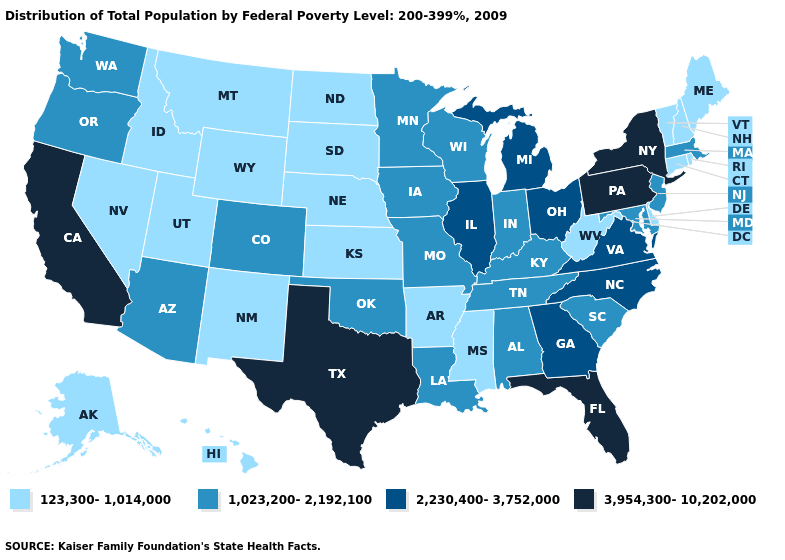What is the value of Hawaii?
Be succinct. 123,300-1,014,000. What is the value of Mississippi?
Concise answer only. 123,300-1,014,000. Which states have the lowest value in the USA?
Quick response, please. Alaska, Arkansas, Connecticut, Delaware, Hawaii, Idaho, Kansas, Maine, Mississippi, Montana, Nebraska, Nevada, New Hampshire, New Mexico, North Dakota, Rhode Island, South Dakota, Utah, Vermont, West Virginia, Wyoming. Name the states that have a value in the range 1,023,200-2,192,100?
Answer briefly. Alabama, Arizona, Colorado, Indiana, Iowa, Kentucky, Louisiana, Maryland, Massachusetts, Minnesota, Missouri, New Jersey, Oklahoma, Oregon, South Carolina, Tennessee, Washington, Wisconsin. Which states have the lowest value in the USA?
Concise answer only. Alaska, Arkansas, Connecticut, Delaware, Hawaii, Idaho, Kansas, Maine, Mississippi, Montana, Nebraska, Nevada, New Hampshire, New Mexico, North Dakota, Rhode Island, South Dakota, Utah, Vermont, West Virginia, Wyoming. Does Rhode Island have a lower value than Missouri?
Keep it brief. Yes. Name the states that have a value in the range 1,023,200-2,192,100?
Answer briefly. Alabama, Arizona, Colorado, Indiana, Iowa, Kentucky, Louisiana, Maryland, Massachusetts, Minnesota, Missouri, New Jersey, Oklahoma, Oregon, South Carolina, Tennessee, Washington, Wisconsin. What is the lowest value in the USA?
Keep it brief. 123,300-1,014,000. What is the highest value in states that border Wisconsin?
Keep it brief. 2,230,400-3,752,000. What is the value of Massachusetts?
Be succinct. 1,023,200-2,192,100. What is the lowest value in the Northeast?
Write a very short answer. 123,300-1,014,000. What is the highest value in the Northeast ?
Give a very brief answer. 3,954,300-10,202,000. Name the states that have a value in the range 123,300-1,014,000?
Quick response, please. Alaska, Arkansas, Connecticut, Delaware, Hawaii, Idaho, Kansas, Maine, Mississippi, Montana, Nebraska, Nevada, New Hampshire, New Mexico, North Dakota, Rhode Island, South Dakota, Utah, Vermont, West Virginia, Wyoming. Among the states that border Idaho , does Oregon have the highest value?
Keep it brief. Yes. What is the value of Texas?
Short answer required. 3,954,300-10,202,000. 